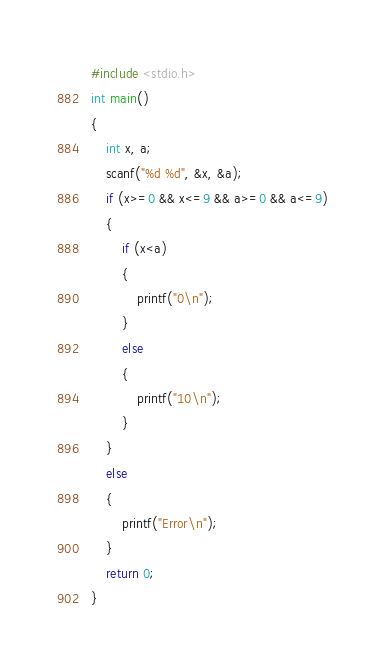<code> <loc_0><loc_0><loc_500><loc_500><_C_>#include <stdio.h>
int main()
{
    int x, a;
    scanf("%d %d", &x, &a);
    if (x>=0 && x<=9 && a>=0 && a<=9)
    {
        if (x<a)
        {
            printf("0\n");
        }
        else
        {
            printf("10\n");
        }
    }
    else
    {
        printf("Error\n");
    }
    return 0;
}
</code> 